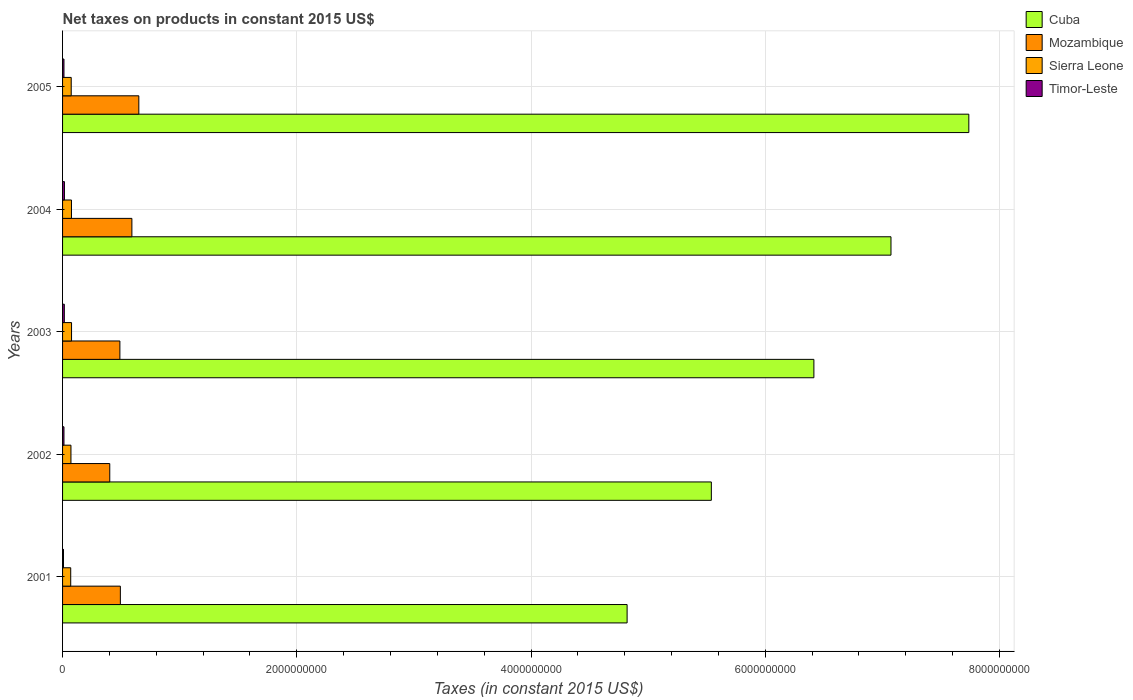How many different coloured bars are there?
Your answer should be compact. 4. Are the number of bars on each tick of the Y-axis equal?
Offer a very short reply. Yes. How many bars are there on the 4th tick from the top?
Give a very brief answer. 4. How many bars are there on the 3rd tick from the bottom?
Your response must be concise. 4. What is the label of the 5th group of bars from the top?
Offer a very short reply. 2001. In how many cases, is the number of bars for a given year not equal to the number of legend labels?
Give a very brief answer. 0. What is the net taxes on products in Mozambique in 2001?
Provide a succinct answer. 4.94e+08. Across all years, what is the maximum net taxes on products in Sierra Leone?
Offer a terse response. 7.67e+07. Across all years, what is the minimum net taxes on products in Sierra Leone?
Provide a short and direct response. 6.96e+07. In which year was the net taxes on products in Cuba maximum?
Your answer should be very brief. 2005. What is the total net taxes on products in Mozambique in the graph?
Your answer should be compact. 2.63e+09. What is the difference between the net taxes on products in Cuba in 2001 and that in 2003?
Provide a short and direct response. -1.60e+09. What is the difference between the net taxes on products in Mozambique in 2004 and the net taxes on products in Timor-Leste in 2002?
Give a very brief answer. 5.80e+08. What is the average net taxes on products in Timor-Leste per year?
Provide a succinct answer. 1.26e+07. In the year 2004, what is the difference between the net taxes on products in Cuba and net taxes on products in Sierra Leone?
Offer a terse response. 7.00e+09. What is the ratio of the net taxes on products in Cuba in 2001 to that in 2005?
Keep it short and to the point. 0.62. Is the net taxes on products in Timor-Leste in 2002 less than that in 2003?
Keep it short and to the point. Yes. Is the difference between the net taxes on products in Cuba in 2001 and 2002 greater than the difference between the net taxes on products in Sierra Leone in 2001 and 2002?
Keep it short and to the point. No. What is the difference between the highest and the second highest net taxes on products in Sierra Leone?
Provide a short and direct response. 6.58e+05. Is the sum of the net taxes on products in Cuba in 2002 and 2004 greater than the maximum net taxes on products in Timor-Leste across all years?
Provide a succinct answer. Yes. Is it the case that in every year, the sum of the net taxes on products in Sierra Leone and net taxes on products in Timor-Leste is greater than the sum of net taxes on products in Mozambique and net taxes on products in Cuba?
Your answer should be very brief. No. What does the 4th bar from the top in 2001 represents?
Give a very brief answer. Cuba. What does the 1st bar from the bottom in 2004 represents?
Keep it short and to the point. Cuba. Is it the case that in every year, the sum of the net taxes on products in Timor-Leste and net taxes on products in Mozambique is greater than the net taxes on products in Sierra Leone?
Make the answer very short. Yes. Are all the bars in the graph horizontal?
Give a very brief answer. Yes. How many years are there in the graph?
Keep it short and to the point. 5. What is the difference between two consecutive major ticks on the X-axis?
Your response must be concise. 2.00e+09. Does the graph contain any zero values?
Keep it short and to the point. No. Does the graph contain grids?
Your answer should be very brief. Yes. What is the title of the graph?
Your answer should be compact. Net taxes on products in constant 2015 US$. Does "Cameroon" appear as one of the legend labels in the graph?
Make the answer very short. No. What is the label or title of the X-axis?
Your answer should be compact. Taxes (in constant 2015 US$). What is the Taxes (in constant 2015 US$) of Cuba in 2001?
Your response must be concise. 4.82e+09. What is the Taxes (in constant 2015 US$) of Mozambique in 2001?
Offer a terse response. 4.94e+08. What is the Taxes (in constant 2015 US$) of Sierra Leone in 2001?
Offer a terse response. 6.96e+07. What is the Taxes (in constant 2015 US$) in Timor-Leste in 2001?
Your response must be concise. 8.00e+06. What is the Taxes (in constant 2015 US$) in Cuba in 2002?
Provide a short and direct response. 5.54e+09. What is the Taxes (in constant 2015 US$) of Mozambique in 2002?
Your answer should be compact. 4.03e+08. What is the Taxes (in constant 2015 US$) of Sierra Leone in 2002?
Offer a very short reply. 7.17e+07. What is the Taxes (in constant 2015 US$) of Cuba in 2003?
Give a very brief answer. 6.42e+09. What is the Taxes (in constant 2015 US$) of Mozambique in 2003?
Ensure brevity in your answer.  4.89e+08. What is the Taxes (in constant 2015 US$) in Sierra Leone in 2003?
Offer a terse response. 7.67e+07. What is the Taxes (in constant 2015 US$) of Timor-Leste in 2003?
Keep it short and to the point. 1.50e+07. What is the Taxes (in constant 2015 US$) in Cuba in 2004?
Offer a very short reply. 7.07e+09. What is the Taxes (in constant 2015 US$) of Mozambique in 2004?
Your answer should be very brief. 5.92e+08. What is the Taxes (in constant 2015 US$) in Sierra Leone in 2004?
Offer a very short reply. 7.61e+07. What is the Taxes (in constant 2015 US$) of Timor-Leste in 2004?
Make the answer very short. 1.60e+07. What is the Taxes (in constant 2015 US$) in Cuba in 2005?
Your answer should be compact. 7.74e+09. What is the Taxes (in constant 2015 US$) of Mozambique in 2005?
Give a very brief answer. 6.51e+08. What is the Taxes (in constant 2015 US$) of Sierra Leone in 2005?
Your answer should be very brief. 7.39e+07. Across all years, what is the maximum Taxes (in constant 2015 US$) in Cuba?
Offer a terse response. 7.74e+09. Across all years, what is the maximum Taxes (in constant 2015 US$) in Mozambique?
Provide a succinct answer. 6.51e+08. Across all years, what is the maximum Taxes (in constant 2015 US$) of Sierra Leone?
Offer a very short reply. 7.67e+07. Across all years, what is the maximum Taxes (in constant 2015 US$) in Timor-Leste?
Offer a very short reply. 1.60e+07. Across all years, what is the minimum Taxes (in constant 2015 US$) in Cuba?
Offer a terse response. 4.82e+09. Across all years, what is the minimum Taxes (in constant 2015 US$) in Mozambique?
Your answer should be compact. 4.03e+08. Across all years, what is the minimum Taxes (in constant 2015 US$) in Sierra Leone?
Offer a very short reply. 6.96e+07. What is the total Taxes (in constant 2015 US$) of Cuba in the graph?
Ensure brevity in your answer.  3.16e+1. What is the total Taxes (in constant 2015 US$) in Mozambique in the graph?
Make the answer very short. 2.63e+09. What is the total Taxes (in constant 2015 US$) in Sierra Leone in the graph?
Make the answer very short. 3.68e+08. What is the total Taxes (in constant 2015 US$) in Timor-Leste in the graph?
Give a very brief answer. 6.30e+07. What is the difference between the Taxes (in constant 2015 US$) in Cuba in 2001 and that in 2002?
Ensure brevity in your answer.  -7.19e+08. What is the difference between the Taxes (in constant 2015 US$) of Mozambique in 2001 and that in 2002?
Keep it short and to the point. 9.05e+07. What is the difference between the Taxes (in constant 2015 US$) of Sierra Leone in 2001 and that in 2002?
Ensure brevity in your answer.  -2.08e+06. What is the difference between the Taxes (in constant 2015 US$) of Cuba in 2001 and that in 2003?
Keep it short and to the point. -1.60e+09. What is the difference between the Taxes (in constant 2015 US$) in Mozambique in 2001 and that in 2003?
Ensure brevity in your answer.  4.09e+06. What is the difference between the Taxes (in constant 2015 US$) in Sierra Leone in 2001 and that in 2003?
Your response must be concise. -7.17e+06. What is the difference between the Taxes (in constant 2015 US$) in Timor-Leste in 2001 and that in 2003?
Offer a very short reply. -7.00e+06. What is the difference between the Taxes (in constant 2015 US$) in Cuba in 2001 and that in 2004?
Provide a succinct answer. -2.25e+09. What is the difference between the Taxes (in constant 2015 US$) of Mozambique in 2001 and that in 2004?
Provide a short and direct response. -9.84e+07. What is the difference between the Taxes (in constant 2015 US$) of Sierra Leone in 2001 and that in 2004?
Provide a succinct answer. -6.51e+06. What is the difference between the Taxes (in constant 2015 US$) of Timor-Leste in 2001 and that in 2004?
Offer a very short reply. -8.00e+06. What is the difference between the Taxes (in constant 2015 US$) in Cuba in 2001 and that in 2005?
Keep it short and to the point. -2.92e+09. What is the difference between the Taxes (in constant 2015 US$) of Mozambique in 2001 and that in 2005?
Your response must be concise. -1.58e+08. What is the difference between the Taxes (in constant 2015 US$) of Sierra Leone in 2001 and that in 2005?
Ensure brevity in your answer.  -4.36e+06. What is the difference between the Taxes (in constant 2015 US$) in Cuba in 2002 and that in 2003?
Your response must be concise. -8.76e+08. What is the difference between the Taxes (in constant 2015 US$) in Mozambique in 2002 and that in 2003?
Your response must be concise. -8.65e+07. What is the difference between the Taxes (in constant 2015 US$) in Sierra Leone in 2002 and that in 2003?
Your response must be concise. -5.09e+06. What is the difference between the Taxes (in constant 2015 US$) in Cuba in 2002 and that in 2004?
Offer a very short reply. -1.53e+09. What is the difference between the Taxes (in constant 2015 US$) in Mozambique in 2002 and that in 2004?
Offer a very short reply. -1.89e+08. What is the difference between the Taxes (in constant 2015 US$) of Sierra Leone in 2002 and that in 2004?
Offer a terse response. -4.43e+06. What is the difference between the Taxes (in constant 2015 US$) of Timor-Leste in 2002 and that in 2004?
Keep it short and to the point. -4.00e+06. What is the difference between the Taxes (in constant 2015 US$) in Cuba in 2002 and that in 2005?
Offer a terse response. -2.20e+09. What is the difference between the Taxes (in constant 2015 US$) of Mozambique in 2002 and that in 2005?
Ensure brevity in your answer.  -2.48e+08. What is the difference between the Taxes (in constant 2015 US$) of Sierra Leone in 2002 and that in 2005?
Offer a terse response. -2.28e+06. What is the difference between the Taxes (in constant 2015 US$) in Cuba in 2003 and that in 2004?
Your answer should be compact. -6.58e+08. What is the difference between the Taxes (in constant 2015 US$) of Mozambique in 2003 and that in 2004?
Offer a terse response. -1.03e+08. What is the difference between the Taxes (in constant 2015 US$) of Sierra Leone in 2003 and that in 2004?
Offer a terse response. 6.58e+05. What is the difference between the Taxes (in constant 2015 US$) of Timor-Leste in 2003 and that in 2004?
Your answer should be compact. -1.00e+06. What is the difference between the Taxes (in constant 2015 US$) in Cuba in 2003 and that in 2005?
Offer a very short reply. -1.32e+09. What is the difference between the Taxes (in constant 2015 US$) of Mozambique in 2003 and that in 2005?
Give a very brief answer. -1.62e+08. What is the difference between the Taxes (in constant 2015 US$) of Sierra Leone in 2003 and that in 2005?
Ensure brevity in your answer.  2.81e+06. What is the difference between the Taxes (in constant 2015 US$) in Timor-Leste in 2003 and that in 2005?
Ensure brevity in your answer.  3.00e+06. What is the difference between the Taxes (in constant 2015 US$) in Cuba in 2004 and that in 2005?
Provide a short and direct response. -6.65e+08. What is the difference between the Taxes (in constant 2015 US$) of Mozambique in 2004 and that in 2005?
Provide a short and direct response. -5.92e+07. What is the difference between the Taxes (in constant 2015 US$) of Sierra Leone in 2004 and that in 2005?
Offer a terse response. 2.15e+06. What is the difference between the Taxes (in constant 2015 US$) in Timor-Leste in 2004 and that in 2005?
Your answer should be compact. 4.00e+06. What is the difference between the Taxes (in constant 2015 US$) in Cuba in 2001 and the Taxes (in constant 2015 US$) in Mozambique in 2002?
Provide a short and direct response. 4.42e+09. What is the difference between the Taxes (in constant 2015 US$) in Cuba in 2001 and the Taxes (in constant 2015 US$) in Sierra Leone in 2002?
Provide a short and direct response. 4.75e+09. What is the difference between the Taxes (in constant 2015 US$) in Cuba in 2001 and the Taxes (in constant 2015 US$) in Timor-Leste in 2002?
Your answer should be very brief. 4.81e+09. What is the difference between the Taxes (in constant 2015 US$) of Mozambique in 2001 and the Taxes (in constant 2015 US$) of Sierra Leone in 2002?
Offer a terse response. 4.22e+08. What is the difference between the Taxes (in constant 2015 US$) in Mozambique in 2001 and the Taxes (in constant 2015 US$) in Timor-Leste in 2002?
Offer a very short reply. 4.82e+08. What is the difference between the Taxes (in constant 2015 US$) in Sierra Leone in 2001 and the Taxes (in constant 2015 US$) in Timor-Leste in 2002?
Provide a succinct answer. 5.76e+07. What is the difference between the Taxes (in constant 2015 US$) of Cuba in 2001 and the Taxes (in constant 2015 US$) of Mozambique in 2003?
Give a very brief answer. 4.33e+09. What is the difference between the Taxes (in constant 2015 US$) of Cuba in 2001 and the Taxes (in constant 2015 US$) of Sierra Leone in 2003?
Your answer should be compact. 4.74e+09. What is the difference between the Taxes (in constant 2015 US$) in Cuba in 2001 and the Taxes (in constant 2015 US$) in Timor-Leste in 2003?
Provide a succinct answer. 4.81e+09. What is the difference between the Taxes (in constant 2015 US$) in Mozambique in 2001 and the Taxes (in constant 2015 US$) in Sierra Leone in 2003?
Your response must be concise. 4.17e+08. What is the difference between the Taxes (in constant 2015 US$) of Mozambique in 2001 and the Taxes (in constant 2015 US$) of Timor-Leste in 2003?
Provide a short and direct response. 4.79e+08. What is the difference between the Taxes (in constant 2015 US$) of Sierra Leone in 2001 and the Taxes (in constant 2015 US$) of Timor-Leste in 2003?
Your response must be concise. 5.46e+07. What is the difference between the Taxes (in constant 2015 US$) in Cuba in 2001 and the Taxes (in constant 2015 US$) in Mozambique in 2004?
Your answer should be very brief. 4.23e+09. What is the difference between the Taxes (in constant 2015 US$) in Cuba in 2001 and the Taxes (in constant 2015 US$) in Sierra Leone in 2004?
Make the answer very short. 4.74e+09. What is the difference between the Taxes (in constant 2015 US$) in Cuba in 2001 and the Taxes (in constant 2015 US$) in Timor-Leste in 2004?
Your answer should be very brief. 4.80e+09. What is the difference between the Taxes (in constant 2015 US$) in Mozambique in 2001 and the Taxes (in constant 2015 US$) in Sierra Leone in 2004?
Keep it short and to the point. 4.17e+08. What is the difference between the Taxes (in constant 2015 US$) in Mozambique in 2001 and the Taxes (in constant 2015 US$) in Timor-Leste in 2004?
Provide a succinct answer. 4.78e+08. What is the difference between the Taxes (in constant 2015 US$) of Sierra Leone in 2001 and the Taxes (in constant 2015 US$) of Timor-Leste in 2004?
Keep it short and to the point. 5.36e+07. What is the difference between the Taxes (in constant 2015 US$) of Cuba in 2001 and the Taxes (in constant 2015 US$) of Mozambique in 2005?
Make the answer very short. 4.17e+09. What is the difference between the Taxes (in constant 2015 US$) in Cuba in 2001 and the Taxes (in constant 2015 US$) in Sierra Leone in 2005?
Provide a succinct answer. 4.75e+09. What is the difference between the Taxes (in constant 2015 US$) of Cuba in 2001 and the Taxes (in constant 2015 US$) of Timor-Leste in 2005?
Ensure brevity in your answer.  4.81e+09. What is the difference between the Taxes (in constant 2015 US$) in Mozambique in 2001 and the Taxes (in constant 2015 US$) in Sierra Leone in 2005?
Your answer should be compact. 4.20e+08. What is the difference between the Taxes (in constant 2015 US$) in Mozambique in 2001 and the Taxes (in constant 2015 US$) in Timor-Leste in 2005?
Offer a terse response. 4.82e+08. What is the difference between the Taxes (in constant 2015 US$) of Sierra Leone in 2001 and the Taxes (in constant 2015 US$) of Timor-Leste in 2005?
Make the answer very short. 5.76e+07. What is the difference between the Taxes (in constant 2015 US$) in Cuba in 2002 and the Taxes (in constant 2015 US$) in Mozambique in 2003?
Provide a short and direct response. 5.05e+09. What is the difference between the Taxes (in constant 2015 US$) in Cuba in 2002 and the Taxes (in constant 2015 US$) in Sierra Leone in 2003?
Keep it short and to the point. 5.46e+09. What is the difference between the Taxes (in constant 2015 US$) of Cuba in 2002 and the Taxes (in constant 2015 US$) of Timor-Leste in 2003?
Your answer should be very brief. 5.52e+09. What is the difference between the Taxes (in constant 2015 US$) of Mozambique in 2002 and the Taxes (in constant 2015 US$) of Sierra Leone in 2003?
Offer a very short reply. 3.26e+08. What is the difference between the Taxes (in constant 2015 US$) in Mozambique in 2002 and the Taxes (in constant 2015 US$) in Timor-Leste in 2003?
Keep it short and to the point. 3.88e+08. What is the difference between the Taxes (in constant 2015 US$) of Sierra Leone in 2002 and the Taxes (in constant 2015 US$) of Timor-Leste in 2003?
Offer a terse response. 5.67e+07. What is the difference between the Taxes (in constant 2015 US$) in Cuba in 2002 and the Taxes (in constant 2015 US$) in Mozambique in 2004?
Ensure brevity in your answer.  4.95e+09. What is the difference between the Taxes (in constant 2015 US$) of Cuba in 2002 and the Taxes (in constant 2015 US$) of Sierra Leone in 2004?
Provide a short and direct response. 5.46e+09. What is the difference between the Taxes (in constant 2015 US$) of Cuba in 2002 and the Taxes (in constant 2015 US$) of Timor-Leste in 2004?
Provide a short and direct response. 5.52e+09. What is the difference between the Taxes (in constant 2015 US$) of Mozambique in 2002 and the Taxes (in constant 2015 US$) of Sierra Leone in 2004?
Offer a very short reply. 3.27e+08. What is the difference between the Taxes (in constant 2015 US$) in Mozambique in 2002 and the Taxes (in constant 2015 US$) in Timor-Leste in 2004?
Keep it short and to the point. 3.87e+08. What is the difference between the Taxes (in constant 2015 US$) in Sierra Leone in 2002 and the Taxes (in constant 2015 US$) in Timor-Leste in 2004?
Give a very brief answer. 5.57e+07. What is the difference between the Taxes (in constant 2015 US$) of Cuba in 2002 and the Taxes (in constant 2015 US$) of Mozambique in 2005?
Your answer should be compact. 4.89e+09. What is the difference between the Taxes (in constant 2015 US$) of Cuba in 2002 and the Taxes (in constant 2015 US$) of Sierra Leone in 2005?
Your answer should be compact. 5.47e+09. What is the difference between the Taxes (in constant 2015 US$) in Cuba in 2002 and the Taxes (in constant 2015 US$) in Timor-Leste in 2005?
Offer a terse response. 5.53e+09. What is the difference between the Taxes (in constant 2015 US$) in Mozambique in 2002 and the Taxes (in constant 2015 US$) in Sierra Leone in 2005?
Your answer should be compact. 3.29e+08. What is the difference between the Taxes (in constant 2015 US$) of Mozambique in 2002 and the Taxes (in constant 2015 US$) of Timor-Leste in 2005?
Provide a short and direct response. 3.91e+08. What is the difference between the Taxes (in constant 2015 US$) of Sierra Leone in 2002 and the Taxes (in constant 2015 US$) of Timor-Leste in 2005?
Your response must be concise. 5.97e+07. What is the difference between the Taxes (in constant 2015 US$) in Cuba in 2003 and the Taxes (in constant 2015 US$) in Mozambique in 2004?
Keep it short and to the point. 5.82e+09. What is the difference between the Taxes (in constant 2015 US$) of Cuba in 2003 and the Taxes (in constant 2015 US$) of Sierra Leone in 2004?
Make the answer very short. 6.34e+09. What is the difference between the Taxes (in constant 2015 US$) in Cuba in 2003 and the Taxes (in constant 2015 US$) in Timor-Leste in 2004?
Provide a short and direct response. 6.40e+09. What is the difference between the Taxes (in constant 2015 US$) in Mozambique in 2003 and the Taxes (in constant 2015 US$) in Sierra Leone in 2004?
Your answer should be compact. 4.13e+08. What is the difference between the Taxes (in constant 2015 US$) of Mozambique in 2003 and the Taxes (in constant 2015 US$) of Timor-Leste in 2004?
Your response must be concise. 4.73e+08. What is the difference between the Taxes (in constant 2015 US$) of Sierra Leone in 2003 and the Taxes (in constant 2015 US$) of Timor-Leste in 2004?
Your response must be concise. 6.07e+07. What is the difference between the Taxes (in constant 2015 US$) of Cuba in 2003 and the Taxes (in constant 2015 US$) of Mozambique in 2005?
Provide a succinct answer. 5.76e+09. What is the difference between the Taxes (in constant 2015 US$) of Cuba in 2003 and the Taxes (in constant 2015 US$) of Sierra Leone in 2005?
Ensure brevity in your answer.  6.34e+09. What is the difference between the Taxes (in constant 2015 US$) in Cuba in 2003 and the Taxes (in constant 2015 US$) in Timor-Leste in 2005?
Provide a short and direct response. 6.40e+09. What is the difference between the Taxes (in constant 2015 US$) in Mozambique in 2003 and the Taxes (in constant 2015 US$) in Sierra Leone in 2005?
Provide a short and direct response. 4.16e+08. What is the difference between the Taxes (in constant 2015 US$) of Mozambique in 2003 and the Taxes (in constant 2015 US$) of Timor-Leste in 2005?
Give a very brief answer. 4.77e+08. What is the difference between the Taxes (in constant 2015 US$) in Sierra Leone in 2003 and the Taxes (in constant 2015 US$) in Timor-Leste in 2005?
Your response must be concise. 6.47e+07. What is the difference between the Taxes (in constant 2015 US$) in Cuba in 2004 and the Taxes (in constant 2015 US$) in Mozambique in 2005?
Your answer should be very brief. 6.42e+09. What is the difference between the Taxes (in constant 2015 US$) of Cuba in 2004 and the Taxes (in constant 2015 US$) of Sierra Leone in 2005?
Your response must be concise. 7.00e+09. What is the difference between the Taxes (in constant 2015 US$) in Cuba in 2004 and the Taxes (in constant 2015 US$) in Timor-Leste in 2005?
Your answer should be compact. 7.06e+09. What is the difference between the Taxes (in constant 2015 US$) in Mozambique in 2004 and the Taxes (in constant 2015 US$) in Sierra Leone in 2005?
Your response must be concise. 5.18e+08. What is the difference between the Taxes (in constant 2015 US$) of Mozambique in 2004 and the Taxes (in constant 2015 US$) of Timor-Leste in 2005?
Ensure brevity in your answer.  5.80e+08. What is the difference between the Taxes (in constant 2015 US$) of Sierra Leone in 2004 and the Taxes (in constant 2015 US$) of Timor-Leste in 2005?
Ensure brevity in your answer.  6.41e+07. What is the average Taxes (in constant 2015 US$) in Cuba per year?
Provide a short and direct response. 6.32e+09. What is the average Taxes (in constant 2015 US$) in Mozambique per year?
Provide a short and direct response. 5.26e+08. What is the average Taxes (in constant 2015 US$) of Sierra Leone per year?
Provide a succinct answer. 7.36e+07. What is the average Taxes (in constant 2015 US$) of Timor-Leste per year?
Keep it short and to the point. 1.26e+07. In the year 2001, what is the difference between the Taxes (in constant 2015 US$) in Cuba and Taxes (in constant 2015 US$) in Mozambique?
Your response must be concise. 4.33e+09. In the year 2001, what is the difference between the Taxes (in constant 2015 US$) in Cuba and Taxes (in constant 2015 US$) in Sierra Leone?
Your response must be concise. 4.75e+09. In the year 2001, what is the difference between the Taxes (in constant 2015 US$) of Cuba and Taxes (in constant 2015 US$) of Timor-Leste?
Ensure brevity in your answer.  4.81e+09. In the year 2001, what is the difference between the Taxes (in constant 2015 US$) of Mozambique and Taxes (in constant 2015 US$) of Sierra Leone?
Provide a succinct answer. 4.24e+08. In the year 2001, what is the difference between the Taxes (in constant 2015 US$) of Mozambique and Taxes (in constant 2015 US$) of Timor-Leste?
Your response must be concise. 4.86e+08. In the year 2001, what is the difference between the Taxes (in constant 2015 US$) in Sierra Leone and Taxes (in constant 2015 US$) in Timor-Leste?
Ensure brevity in your answer.  6.16e+07. In the year 2002, what is the difference between the Taxes (in constant 2015 US$) in Cuba and Taxes (in constant 2015 US$) in Mozambique?
Your response must be concise. 5.14e+09. In the year 2002, what is the difference between the Taxes (in constant 2015 US$) of Cuba and Taxes (in constant 2015 US$) of Sierra Leone?
Keep it short and to the point. 5.47e+09. In the year 2002, what is the difference between the Taxes (in constant 2015 US$) of Cuba and Taxes (in constant 2015 US$) of Timor-Leste?
Keep it short and to the point. 5.53e+09. In the year 2002, what is the difference between the Taxes (in constant 2015 US$) of Mozambique and Taxes (in constant 2015 US$) of Sierra Leone?
Ensure brevity in your answer.  3.31e+08. In the year 2002, what is the difference between the Taxes (in constant 2015 US$) of Mozambique and Taxes (in constant 2015 US$) of Timor-Leste?
Provide a short and direct response. 3.91e+08. In the year 2002, what is the difference between the Taxes (in constant 2015 US$) of Sierra Leone and Taxes (in constant 2015 US$) of Timor-Leste?
Provide a short and direct response. 5.97e+07. In the year 2003, what is the difference between the Taxes (in constant 2015 US$) of Cuba and Taxes (in constant 2015 US$) of Mozambique?
Your answer should be compact. 5.93e+09. In the year 2003, what is the difference between the Taxes (in constant 2015 US$) in Cuba and Taxes (in constant 2015 US$) in Sierra Leone?
Offer a terse response. 6.34e+09. In the year 2003, what is the difference between the Taxes (in constant 2015 US$) in Cuba and Taxes (in constant 2015 US$) in Timor-Leste?
Keep it short and to the point. 6.40e+09. In the year 2003, what is the difference between the Taxes (in constant 2015 US$) of Mozambique and Taxes (in constant 2015 US$) of Sierra Leone?
Offer a terse response. 4.13e+08. In the year 2003, what is the difference between the Taxes (in constant 2015 US$) of Mozambique and Taxes (in constant 2015 US$) of Timor-Leste?
Offer a very short reply. 4.74e+08. In the year 2003, what is the difference between the Taxes (in constant 2015 US$) in Sierra Leone and Taxes (in constant 2015 US$) in Timor-Leste?
Your answer should be compact. 6.17e+07. In the year 2004, what is the difference between the Taxes (in constant 2015 US$) of Cuba and Taxes (in constant 2015 US$) of Mozambique?
Keep it short and to the point. 6.48e+09. In the year 2004, what is the difference between the Taxes (in constant 2015 US$) of Cuba and Taxes (in constant 2015 US$) of Sierra Leone?
Make the answer very short. 7.00e+09. In the year 2004, what is the difference between the Taxes (in constant 2015 US$) in Cuba and Taxes (in constant 2015 US$) in Timor-Leste?
Offer a very short reply. 7.06e+09. In the year 2004, what is the difference between the Taxes (in constant 2015 US$) of Mozambique and Taxes (in constant 2015 US$) of Sierra Leone?
Give a very brief answer. 5.16e+08. In the year 2004, what is the difference between the Taxes (in constant 2015 US$) of Mozambique and Taxes (in constant 2015 US$) of Timor-Leste?
Your response must be concise. 5.76e+08. In the year 2004, what is the difference between the Taxes (in constant 2015 US$) of Sierra Leone and Taxes (in constant 2015 US$) of Timor-Leste?
Offer a terse response. 6.01e+07. In the year 2005, what is the difference between the Taxes (in constant 2015 US$) of Cuba and Taxes (in constant 2015 US$) of Mozambique?
Give a very brief answer. 7.09e+09. In the year 2005, what is the difference between the Taxes (in constant 2015 US$) in Cuba and Taxes (in constant 2015 US$) in Sierra Leone?
Ensure brevity in your answer.  7.66e+09. In the year 2005, what is the difference between the Taxes (in constant 2015 US$) of Cuba and Taxes (in constant 2015 US$) of Timor-Leste?
Make the answer very short. 7.73e+09. In the year 2005, what is the difference between the Taxes (in constant 2015 US$) in Mozambique and Taxes (in constant 2015 US$) in Sierra Leone?
Make the answer very short. 5.77e+08. In the year 2005, what is the difference between the Taxes (in constant 2015 US$) in Mozambique and Taxes (in constant 2015 US$) in Timor-Leste?
Make the answer very short. 6.39e+08. In the year 2005, what is the difference between the Taxes (in constant 2015 US$) in Sierra Leone and Taxes (in constant 2015 US$) in Timor-Leste?
Your answer should be very brief. 6.19e+07. What is the ratio of the Taxes (in constant 2015 US$) of Cuba in 2001 to that in 2002?
Offer a very short reply. 0.87. What is the ratio of the Taxes (in constant 2015 US$) of Mozambique in 2001 to that in 2002?
Your answer should be very brief. 1.22. What is the ratio of the Taxes (in constant 2015 US$) in Cuba in 2001 to that in 2003?
Your response must be concise. 0.75. What is the ratio of the Taxes (in constant 2015 US$) in Mozambique in 2001 to that in 2003?
Keep it short and to the point. 1.01. What is the ratio of the Taxes (in constant 2015 US$) in Sierra Leone in 2001 to that in 2003?
Make the answer very short. 0.91. What is the ratio of the Taxes (in constant 2015 US$) of Timor-Leste in 2001 to that in 2003?
Offer a very short reply. 0.53. What is the ratio of the Taxes (in constant 2015 US$) in Cuba in 2001 to that in 2004?
Give a very brief answer. 0.68. What is the ratio of the Taxes (in constant 2015 US$) of Mozambique in 2001 to that in 2004?
Your response must be concise. 0.83. What is the ratio of the Taxes (in constant 2015 US$) in Sierra Leone in 2001 to that in 2004?
Your response must be concise. 0.91. What is the ratio of the Taxes (in constant 2015 US$) in Timor-Leste in 2001 to that in 2004?
Your answer should be compact. 0.5. What is the ratio of the Taxes (in constant 2015 US$) in Cuba in 2001 to that in 2005?
Keep it short and to the point. 0.62. What is the ratio of the Taxes (in constant 2015 US$) of Mozambique in 2001 to that in 2005?
Keep it short and to the point. 0.76. What is the ratio of the Taxes (in constant 2015 US$) of Sierra Leone in 2001 to that in 2005?
Your answer should be very brief. 0.94. What is the ratio of the Taxes (in constant 2015 US$) in Timor-Leste in 2001 to that in 2005?
Keep it short and to the point. 0.67. What is the ratio of the Taxes (in constant 2015 US$) in Cuba in 2002 to that in 2003?
Your answer should be very brief. 0.86. What is the ratio of the Taxes (in constant 2015 US$) in Mozambique in 2002 to that in 2003?
Offer a terse response. 0.82. What is the ratio of the Taxes (in constant 2015 US$) in Sierra Leone in 2002 to that in 2003?
Your response must be concise. 0.93. What is the ratio of the Taxes (in constant 2015 US$) in Timor-Leste in 2002 to that in 2003?
Provide a succinct answer. 0.8. What is the ratio of the Taxes (in constant 2015 US$) in Cuba in 2002 to that in 2004?
Provide a succinct answer. 0.78. What is the ratio of the Taxes (in constant 2015 US$) in Mozambique in 2002 to that in 2004?
Offer a terse response. 0.68. What is the ratio of the Taxes (in constant 2015 US$) of Sierra Leone in 2002 to that in 2004?
Your answer should be very brief. 0.94. What is the ratio of the Taxes (in constant 2015 US$) in Cuba in 2002 to that in 2005?
Your answer should be compact. 0.72. What is the ratio of the Taxes (in constant 2015 US$) in Mozambique in 2002 to that in 2005?
Your response must be concise. 0.62. What is the ratio of the Taxes (in constant 2015 US$) in Sierra Leone in 2002 to that in 2005?
Your answer should be very brief. 0.97. What is the ratio of the Taxes (in constant 2015 US$) in Cuba in 2003 to that in 2004?
Your answer should be very brief. 0.91. What is the ratio of the Taxes (in constant 2015 US$) of Mozambique in 2003 to that in 2004?
Offer a very short reply. 0.83. What is the ratio of the Taxes (in constant 2015 US$) in Sierra Leone in 2003 to that in 2004?
Give a very brief answer. 1.01. What is the ratio of the Taxes (in constant 2015 US$) in Timor-Leste in 2003 to that in 2004?
Your answer should be compact. 0.94. What is the ratio of the Taxes (in constant 2015 US$) of Cuba in 2003 to that in 2005?
Your answer should be compact. 0.83. What is the ratio of the Taxes (in constant 2015 US$) of Mozambique in 2003 to that in 2005?
Your answer should be very brief. 0.75. What is the ratio of the Taxes (in constant 2015 US$) in Sierra Leone in 2003 to that in 2005?
Your response must be concise. 1.04. What is the ratio of the Taxes (in constant 2015 US$) in Timor-Leste in 2003 to that in 2005?
Keep it short and to the point. 1.25. What is the ratio of the Taxes (in constant 2015 US$) of Cuba in 2004 to that in 2005?
Give a very brief answer. 0.91. What is the ratio of the Taxes (in constant 2015 US$) in Sierra Leone in 2004 to that in 2005?
Provide a short and direct response. 1.03. What is the ratio of the Taxes (in constant 2015 US$) of Timor-Leste in 2004 to that in 2005?
Make the answer very short. 1.33. What is the difference between the highest and the second highest Taxes (in constant 2015 US$) in Cuba?
Offer a terse response. 6.65e+08. What is the difference between the highest and the second highest Taxes (in constant 2015 US$) in Mozambique?
Your response must be concise. 5.92e+07. What is the difference between the highest and the second highest Taxes (in constant 2015 US$) in Sierra Leone?
Give a very brief answer. 6.58e+05. What is the difference between the highest and the second highest Taxes (in constant 2015 US$) in Timor-Leste?
Your answer should be compact. 1.00e+06. What is the difference between the highest and the lowest Taxes (in constant 2015 US$) in Cuba?
Offer a very short reply. 2.92e+09. What is the difference between the highest and the lowest Taxes (in constant 2015 US$) of Mozambique?
Provide a succinct answer. 2.48e+08. What is the difference between the highest and the lowest Taxes (in constant 2015 US$) in Sierra Leone?
Ensure brevity in your answer.  7.17e+06. What is the difference between the highest and the lowest Taxes (in constant 2015 US$) in Timor-Leste?
Your answer should be compact. 8.00e+06. 